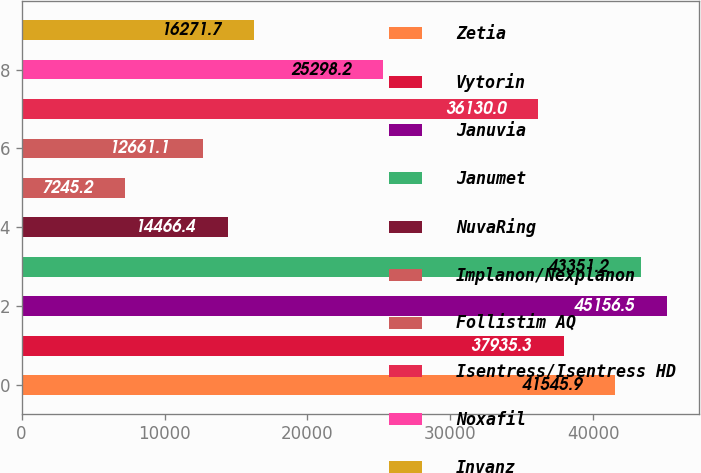Convert chart. <chart><loc_0><loc_0><loc_500><loc_500><bar_chart><fcel>Zetia<fcel>Vytorin<fcel>Januvia<fcel>Janumet<fcel>NuvaRing<fcel>Implanon/Nexplanon<fcel>Follistim AQ<fcel>Isentress/Isentress HD<fcel>Noxafil<fcel>Invanz<nl><fcel>41545.9<fcel>37935.3<fcel>45156.5<fcel>43351.2<fcel>14466.4<fcel>7245.2<fcel>12661.1<fcel>36130<fcel>25298.2<fcel>16271.7<nl></chart> 